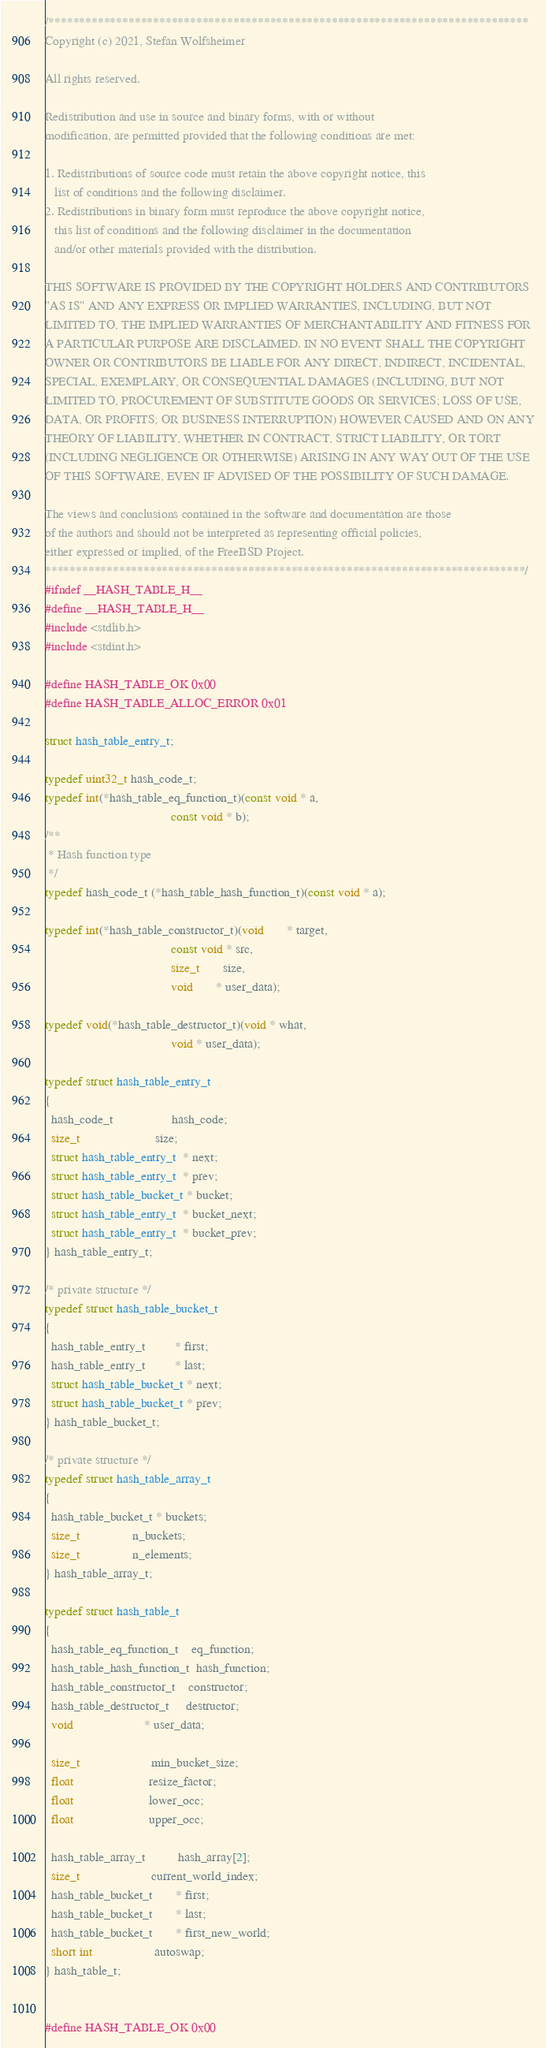Convert code to text. <code><loc_0><loc_0><loc_500><loc_500><_C_>/******************************************************************************
Copyright (c) 2021, Stefan Wolfsheimer

All rights reserved.

Redistribution and use in source and binary forms, with or without
modification, are permitted provided that the following conditions are met:

1. Redistributions of source code must retain the above copyright notice, this
   list of conditions and the following disclaimer.
2. Redistributions in binary form must reproduce the above copyright notice,
   this list of conditions and the following disclaimer in the documentation
   and/or other materials provided with the distribution.

THIS SOFTWARE IS PROVIDED BY THE COPYRIGHT HOLDERS AND CONTRIBUTORS
"AS IS" AND ANY EXPRESS OR IMPLIED WARRANTIES, INCLUDING, BUT NOT
LIMITED TO, THE IMPLIED WARRANTIES OF MERCHANTABILITY AND FITNESS FOR
A PARTICULAR PURPOSE ARE DISCLAIMED. IN NO EVENT SHALL THE COPYRIGHT
OWNER OR CONTRIBUTORS BE LIABLE FOR ANY DIRECT, INDIRECT, INCIDENTAL,
SPECIAL, EXEMPLARY, OR CONSEQUENTIAL DAMAGES (INCLUDING, BUT NOT
LIMITED TO, PROCUREMENT OF SUBSTITUTE GOODS OR SERVICES; LOSS OF USE,
DATA, OR PROFITS; OR BUSINESS INTERRUPTION) HOWEVER CAUSED AND ON ANY
THEORY OF LIABILITY, WHETHER IN CONTRACT, STRICT LIABILITY, OR TORT
(INCLUDING NEGLIGENCE OR OTHERWISE) ARISING IN ANY WAY OUT OF THE USE
OF THIS SOFTWARE, EVEN IF ADVISED OF THE POSSIBILITY OF SUCH DAMAGE.

The views and conclusions contained in the software and documentation are those
of the authors and should not be interpreted as representing official policies,
either expressed or implied, of the FreeBSD Project.
******************************************************************************/
#ifndef __HASH_TABLE_H__
#define __HASH_TABLE_H__
#include <stdlib.h>
#include <stdint.h>

#define HASH_TABLE_OK 0x00
#define HASH_TABLE_ALLOC_ERROR 0x01

struct hash_table_entry_t;

typedef uint32_t hash_code_t;
typedef int(*hash_table_eq_function_t)(const void * a,
                                       const void * b);
/**
 * Hash function type
 */
typedef hash_code_t (*hash_table_hash_function_t)(const void * a);

typedef int(*hash_table_constructor_t)(void       * target,
                                       const void * src, 
                                       size_t       size,
                                       void       * user_data);

typedef void(*hash_table_destructor_t)(void * what,
                                       void * user_data);

typedef struct hash_table_entry_t
{
  hash_code_t                  hash_code;
  size_t                       size;
  struct hash_table_entry_t  * next;
  struct hash_table_entry_t  * prev;
  struct hash_table_bucket_t * bucket;
  struct hash_table_entry_t  * bucket_next;
  struct hash_table_entry_t  * bucket_prev;
} hash_table_entry_t;

/* private structure */
typedef struct hash_table_bucket_t 
{
  hash_table_entry_t         * first;
  hash_table_entry_t         * last;
  struct hash_table_bucket_t * next;
  struct hash_table_bucket_t * prev;
} hash_table_bucket_t;

/* private structure */
typedef struct hash_table_array_t 
{
  hash_table_bucket_t * buckets;
  size_t                n_buckets;
  size_t                n_elements;
} hash_table_array_t;

typedef struct hash_table_t
{
  hash_table_eq_function_t    eq_function;
  hash_table_hash_function_t  hash_function;
  hash_table_constructor_t    constructor;
  hash_table_destructor_t     destructor;
  void                      * user_data;

  size_t                      min_bucket_size;
  float                       resize_factor;
  float                       lower_occ;
  float                       upper_occ;

  hash_table_array_t          hash_array[2];
  size_t                      current_world_index;
  hash_table_bucket_t       * first;
  hash_table_bucket_t       * last;
  hash_table_bucket_t       * first_new_world;
  short int                   autoswap;
} hash_table_t;


#define HASH_TABLE_OK 0x00</code> 